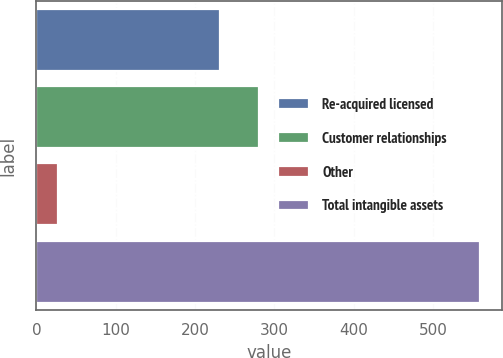Convert chart. <chart><loc_0><loc_0><loc_500><loc_500><bar_chart><fcel>Re-acquired licensed<fcel>Customer relationships<fcel>Other<fcel>Total intangible assets<nl><fcel>231.1<fcel>280.15<fcel>26.9<fcel>559.15<nl></chart> 